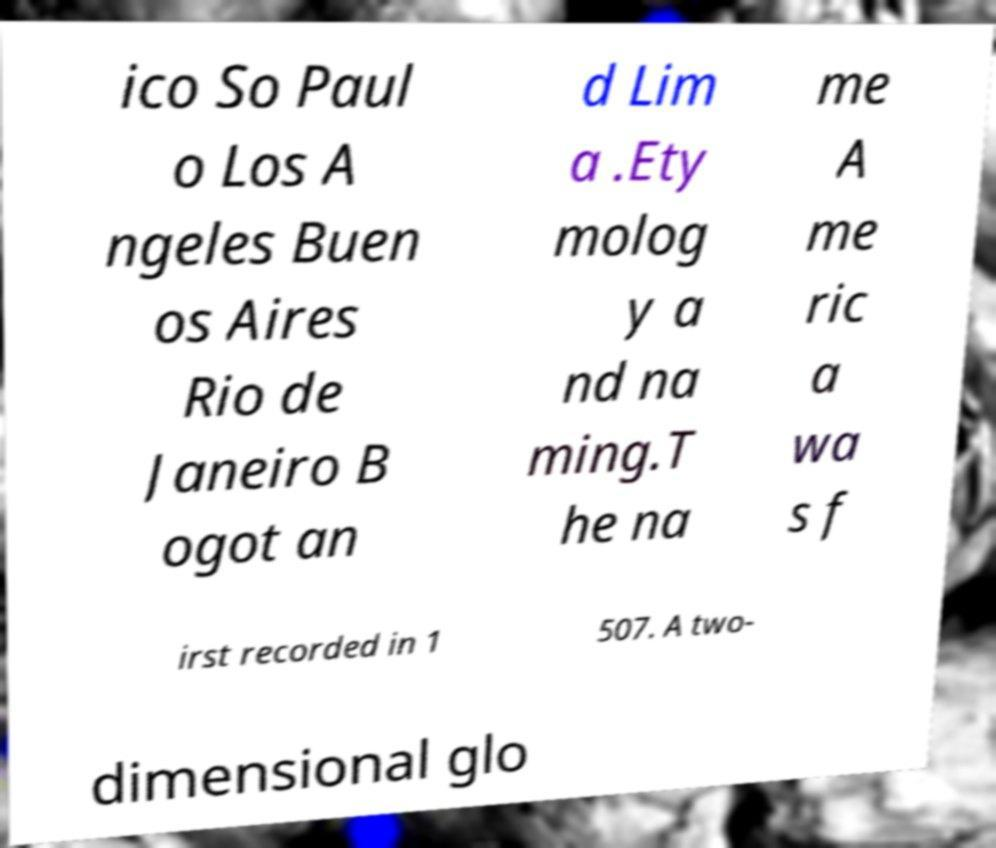Can you read and provide the text displayed in the image?This photo seems to have some interesting text. Can you extract and type it out for me? ico So Paul o Los A ngeles Buen os Aires Rio de Janeiro B ogot an d Lim a .Ety molog y a nd na ming.T he na me A me ric a wa s f irst recorded in 1 507. A two- dimensional glo 